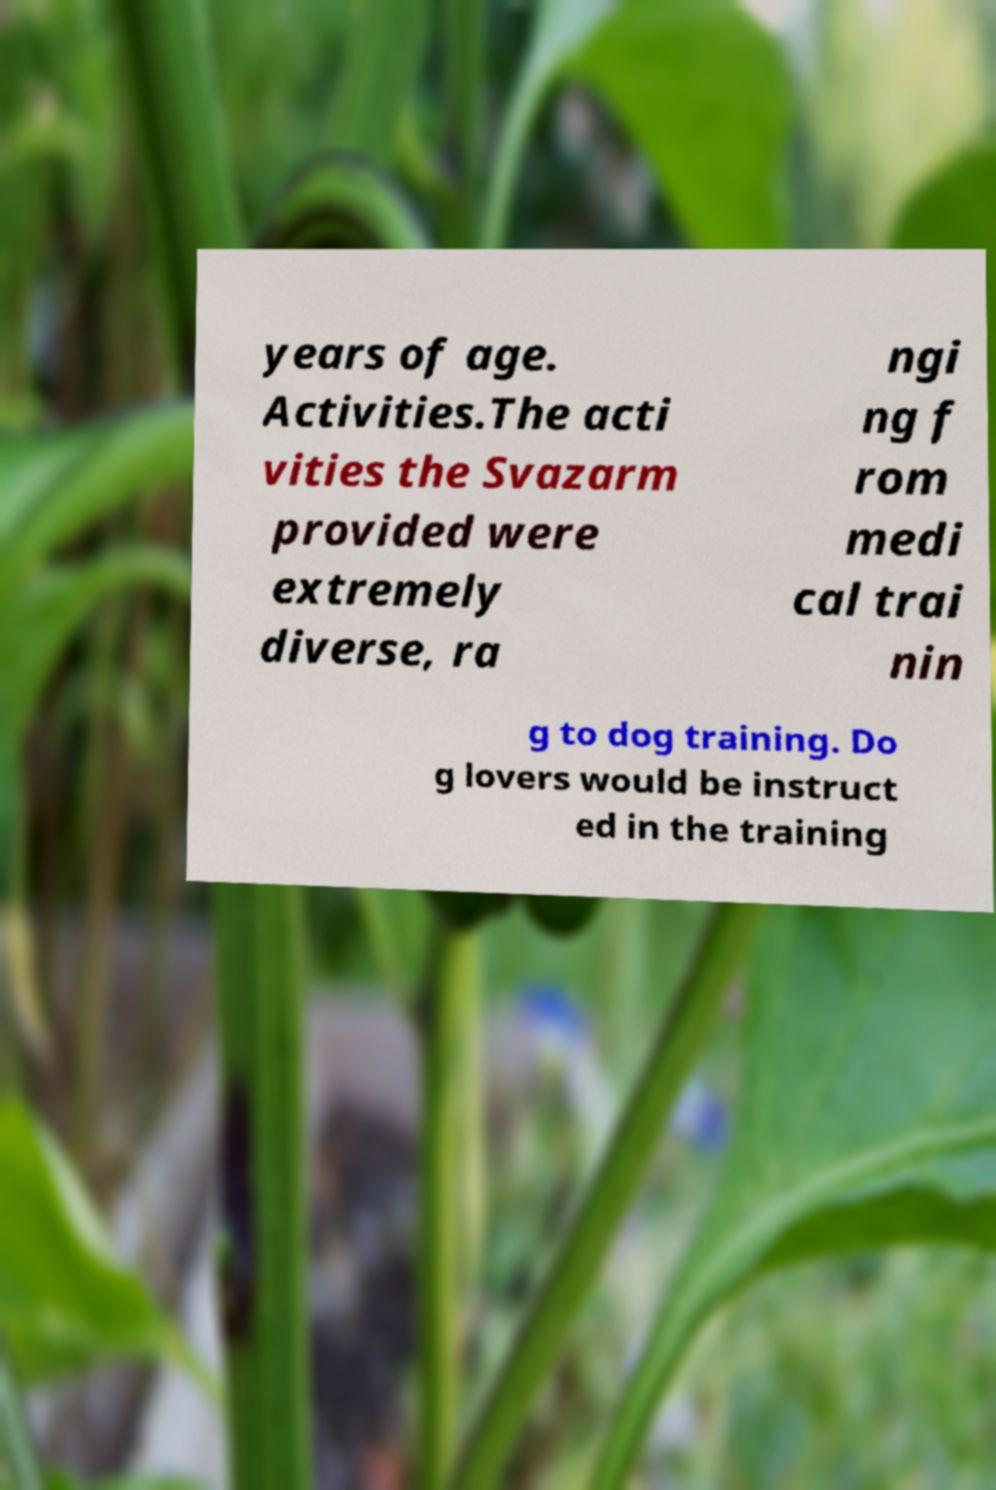Can you accurately transcribe the text from the provided image for me? years of age. Activities.The acti vities the Svazarm provided were extremely diverse, ra ngi ng f rom medi cal trai nin g to dog training. Do g lovers would be instruct ed in the training 